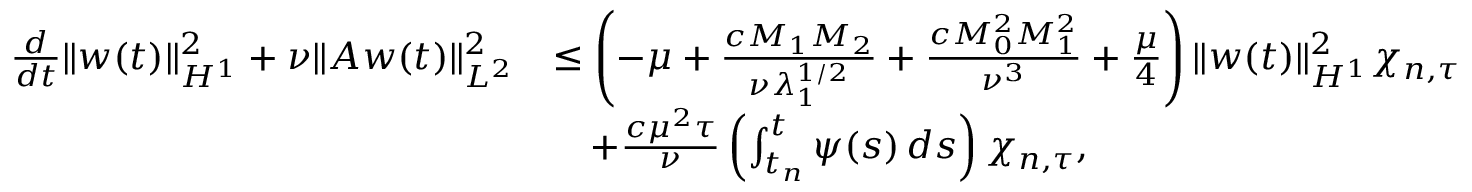Convert formula to latex. <formula><loc_0><loc_0><loc_500><loc_500>\begin{array} { r l } { \frac { d } { d t } \| w ( t ) \| _ { H ^ { 1 } } ^ { 2 } + \nu \| A w ( t ) \| _ { L ^ { 2 } } ^ { 2 } } & { \leq \left ( - \mu + \frac { c M _ { 1 } M _ { 2 } } { \nu \lambda _ { 1 } ^ { 1 / 2 } } + \frac { c M _ { 0 } ^ { 2 } M _ { 1 } ^ { 2 } } { \nu ^ { 3 } } + \frac { \mu } { 4 } \right ) \| w ( t ) \| _ { H ^ { 1 } } ^ { 2 } \chi _ { n , \tau } } \\ & { \quad + \frac { c \mu ^ { 2 } \tau } { \nu } \left ( \int _ { t _ { n } } ^ { t } \psi ( s ) \, d s \right ) \chi _ { n , \tau } , } \end{array}</formula> 